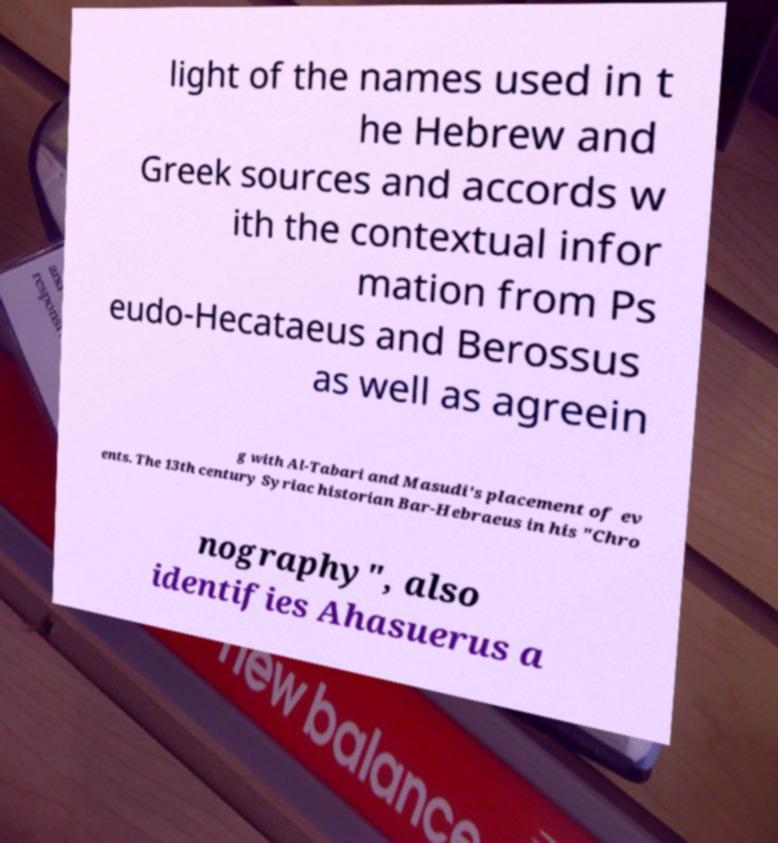For documentation purposes, I need the text within this image transcribed. Could you provide that? light of the names used in t he Hebrew and Greek sources and accords w ith the contextual infor mation from Ps eudo-Hecataeus and Berossus as well as agreein g with Al-Tabari and Masudi's placement of ev ents. The 13th century Syriac historian Bar-Hebraeus in his "Chro nography", also identifies Ahasuerus a 